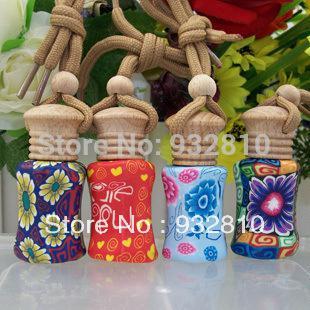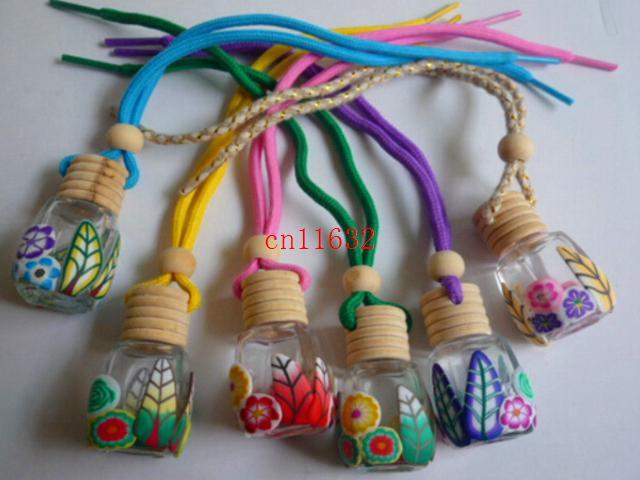The first image is the image on the left, the second image is the image on the right. For the images shown, is this caption "All bottles have wooden caps and at least one bottle has a braided strap attached." true? Answer yes or no. Yes. The first image is the image on the left, the second image is the image on the right. Given the left and right images, does the statement "At least 4 bottles are lined up in a straight row." hold true? Answer yes or no. Yes. 